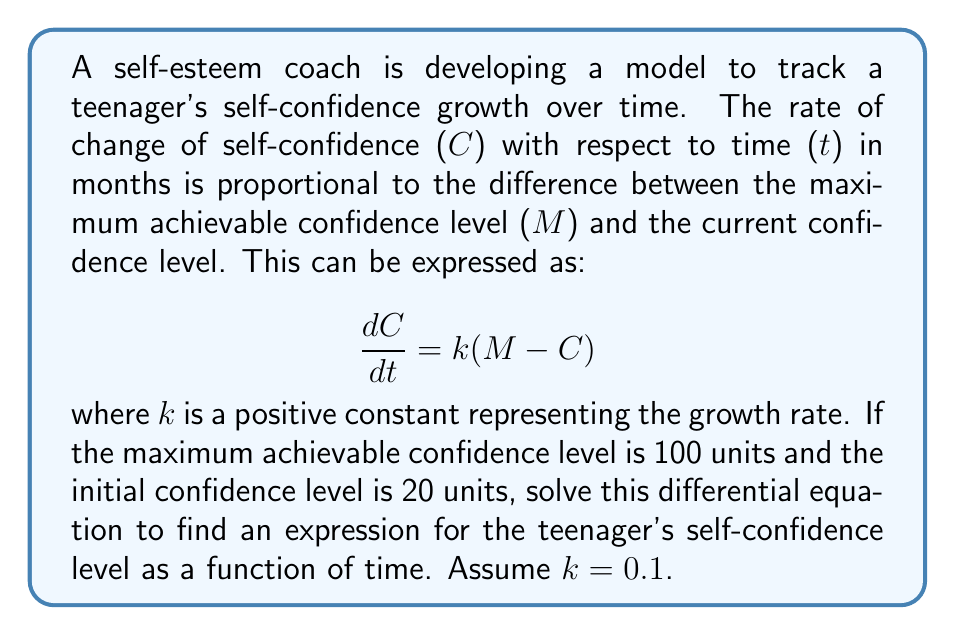Can you answer this question? Let's solve this differential equation step by step:

1) We have the differential equation: $\frac{dC}{dt} = k(M - C)$
   where $M = 100$, $k = 0.1$, and initial condition $C(0) = 20$

2) Rearrange the equation:
   $$\frac{dC}{M - C} = k dt$$

3) Integrate both sides:
   $$\int \frac{dC}{M - C} = \int k dt$$

4) The left side integrates to $-\ln|M - C|$, and the right side to $kt + D$:
   $$-\ln|M - C| = kt + D$$

5) Solve for $C$:
   $$\ln|M - C| = -kt - D$$
   $$M - C = e^{-kt - D} = Ae^{-kt}$$, where $A = e^{-D}$
   $$C = M - Ae^{-kt}$$

6) Use the initial condition to find $A$:
   $20 = 100 - A$ when $t = 0$
   $A = 80$

7) Therefore, the final solution is:
   $$C = 100 - 80e^{-0.1t}$$

This equation represents the teenager's self-confidence level as a function of time in months.
Answer: $C = 100 - 80e^{-0.1t}$, where $C$ is the self-confidence level and $t$ is time in months. 